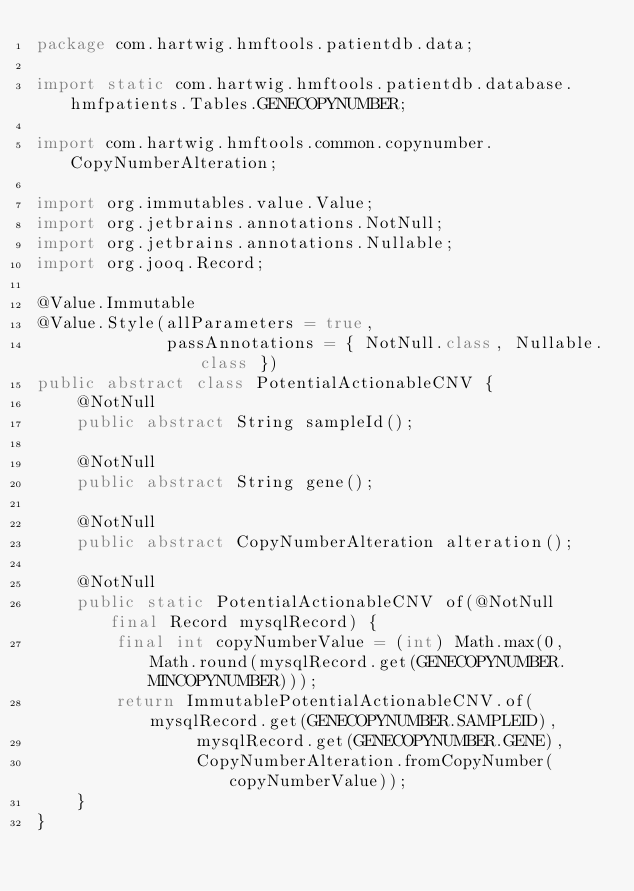Convert code to text. <code><loc_0><loc_0><loc_500><loc_500><_Java_>package com.hartwig.hmftools.patientdb.data;

import static com.hartwig.hmftools.patientdb.database.hmfpatients.Tables.GENECOPYNUMBER;

import com.hartwig.hmftools.common.copynumber.CopyNumberAlteration;

import org.immutables.value.Value;
import org.jetbrains.annotations.NotNull;
import org.jetbrains.annotations.Nullable;
import org.jooq.Record;

@Value.Immutable
@Value.Style(allParameters = true,
             passAnnotations = { NotNull.class, Nullable.class })
public abstract class PotentialActionableCNV {
    @NotNull
    public abstract String sampleId();

    @NotNull
    public abstract String gene();

    @NotNull
    public abstract CopyNumberAlteration alteration();

    @NotNull
    public static PotentialActionableCNV of(@NotNull final Record mysqlRecord) {
        final int copyNumberValue = (int) Math.max(0, Math.round(mysqlRecord.get(GENECOPYNUMBER.MINCOPYNUMBER)));
        return ImmutablePotentialActionableCNV.of(mysqlRecord.get(GENECOPYNUMBER.SAMPLEID),
                mysqlRecord.get(GENECOPYNUMBER.GENE),
                CopyNumberAlteration.fromCopyNumber(copyNumberValue));
    }
}
</code> 